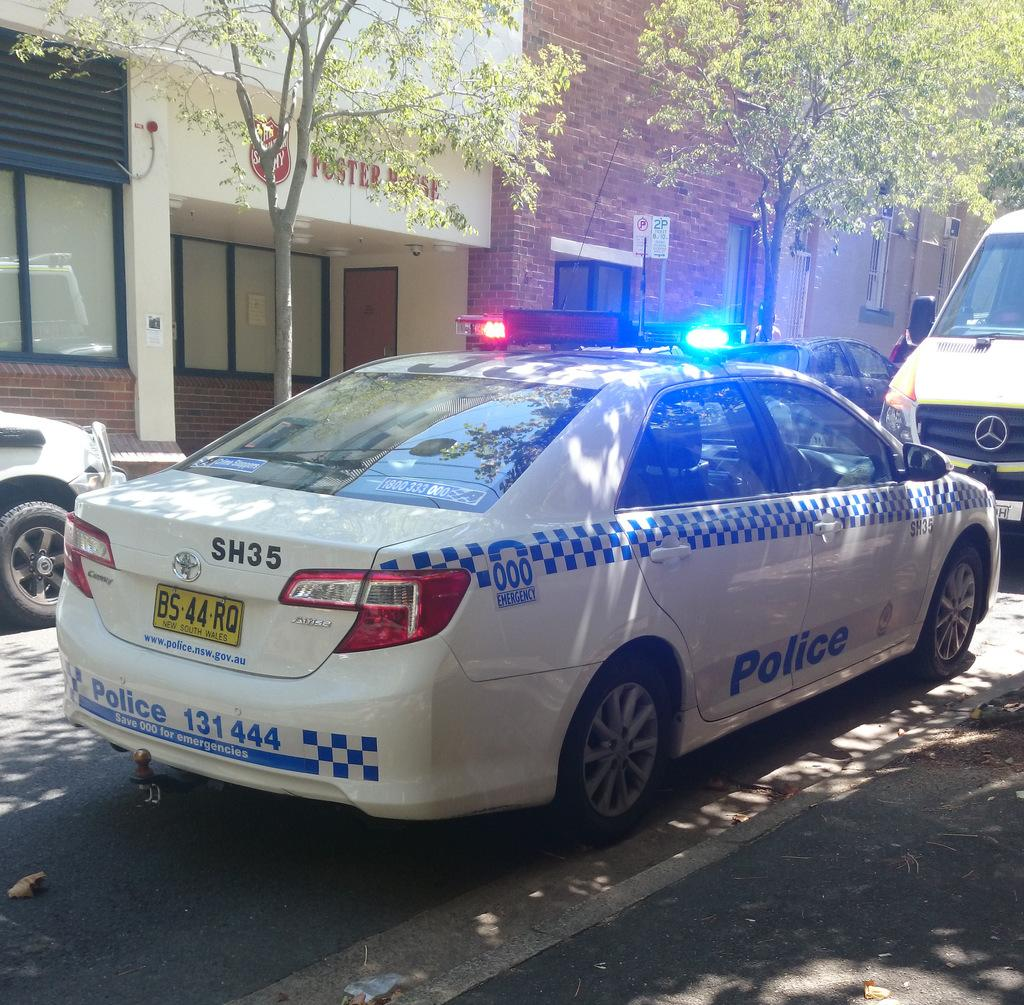What is happening in the image? There are vehicles on a road in the image. What can be seen in the background of the image? There are trees and buildings in the background of the image. What type of nut is causing the vehicles to move in the image? There is no nut present in the image, and the vehicles are not being caused to move by any nut. 